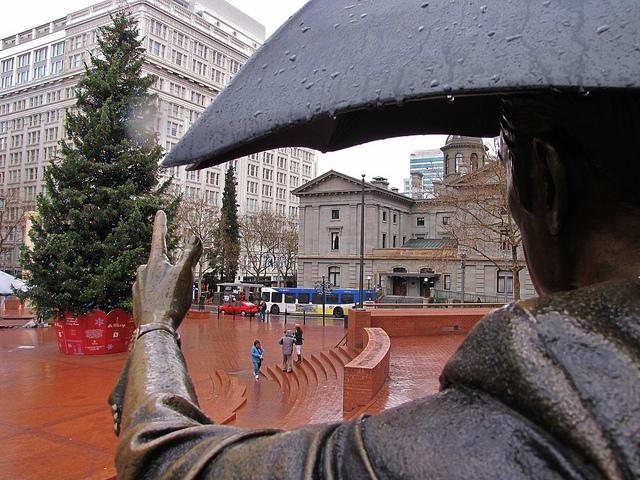When does this season take place?

Choices:
A) spring
B) summer
C) fall
D) winter winter 